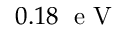Convert formula to latex. <formula><loc_0><loc_0><loc_500><loc_500>0 . 1 8 \, e V</formula> 